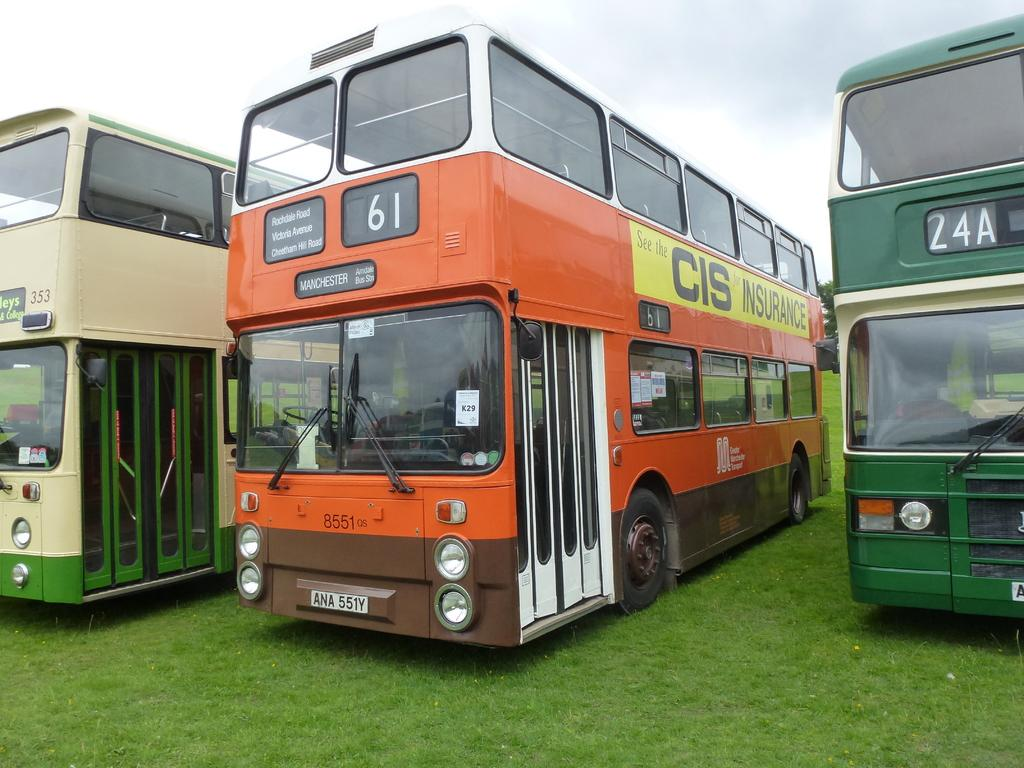How many vehicles are present in the image? There are three vehicles in the image. What colors are the vehicles? The vehicles are in green and orange colors. What can be seen in the background of the image? There is grass and trees in the background of the image. What is visible above the vehicles and background? The sky is visible in the image, and it appears to be white. How does the gate in the image show respect to the vehicles? There is no gate present in the image, so it cannot show respect to the vehicles. 